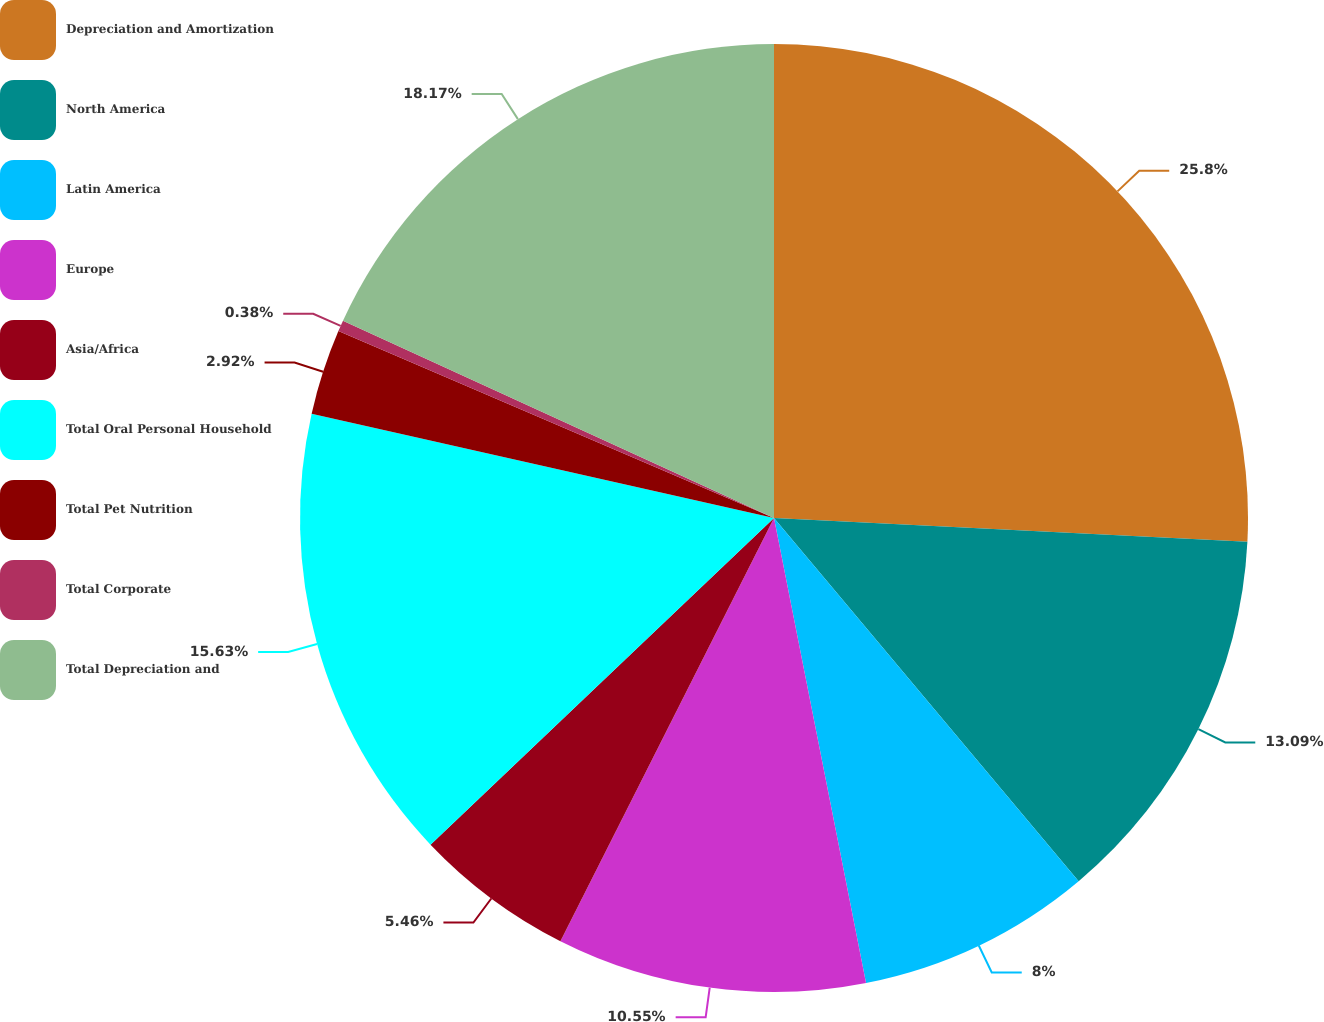Convert chart. <chart><loc_0><loc_0><loc_500><loc_500><pie_chart><fcel>Depreciation and Amortization<fcel>North America<fcel>Latin America<fcel>Europe<fcel>Asia/Africa<fcel>Total Oral Personal Household<fcel>Total Pet Nutrition<fcel>Total Corporate<fcel>Total Depreciation and<nl><fcel>25.8%<fcel>13.09%<fcel>8.0%<fcel>10.55%<fcel>5.46%<fcel>15.63%<fcel>2.92%<fcel>0.38%<fcel>18.17%<nl></chart> 